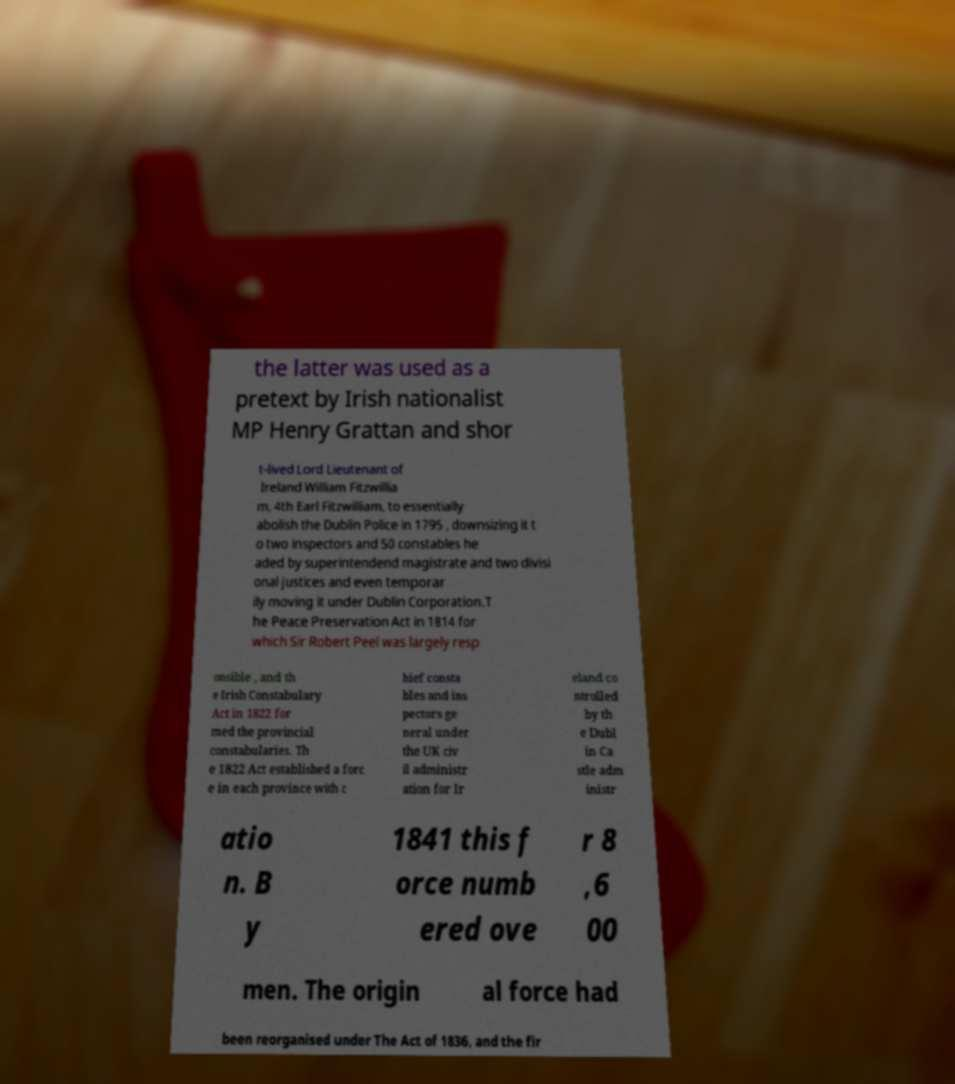What messages or text are displayed in this image? I need them in a readable, typed format. the latter was used as a pretext by Irish nationalist MP Henry Grattan and shor t-lived Lord Lieutenant of Ireland William Fitzwillia m, 4th Earl Fitzwilliam, to essentially abolish the Dublin Police in 1795 , downsizing it t o two inspectors and 50 constables he aded by superintendend magistrate and two divisi onal justices and even temporar ily moving it under Dublin Corporation.T he Peace Preservation Act in 1814 for which Sir Robert Peel was largely resp onsible , and th e Irish Constabulary Act in 1822 for med the provincial constabularies. Th e 1822 Act established a forc e in each province with c hief consta bles and ins pectors ge neral under the UK civ il administr ation for Ir eland co ntrolled by th e Dubl in Ca stle adm inistr atio n. B y 1841 this f orce numb ered ove r 8 ,6 00 men. The origin al force had been reorganised under The Act of 1836, and the fir 